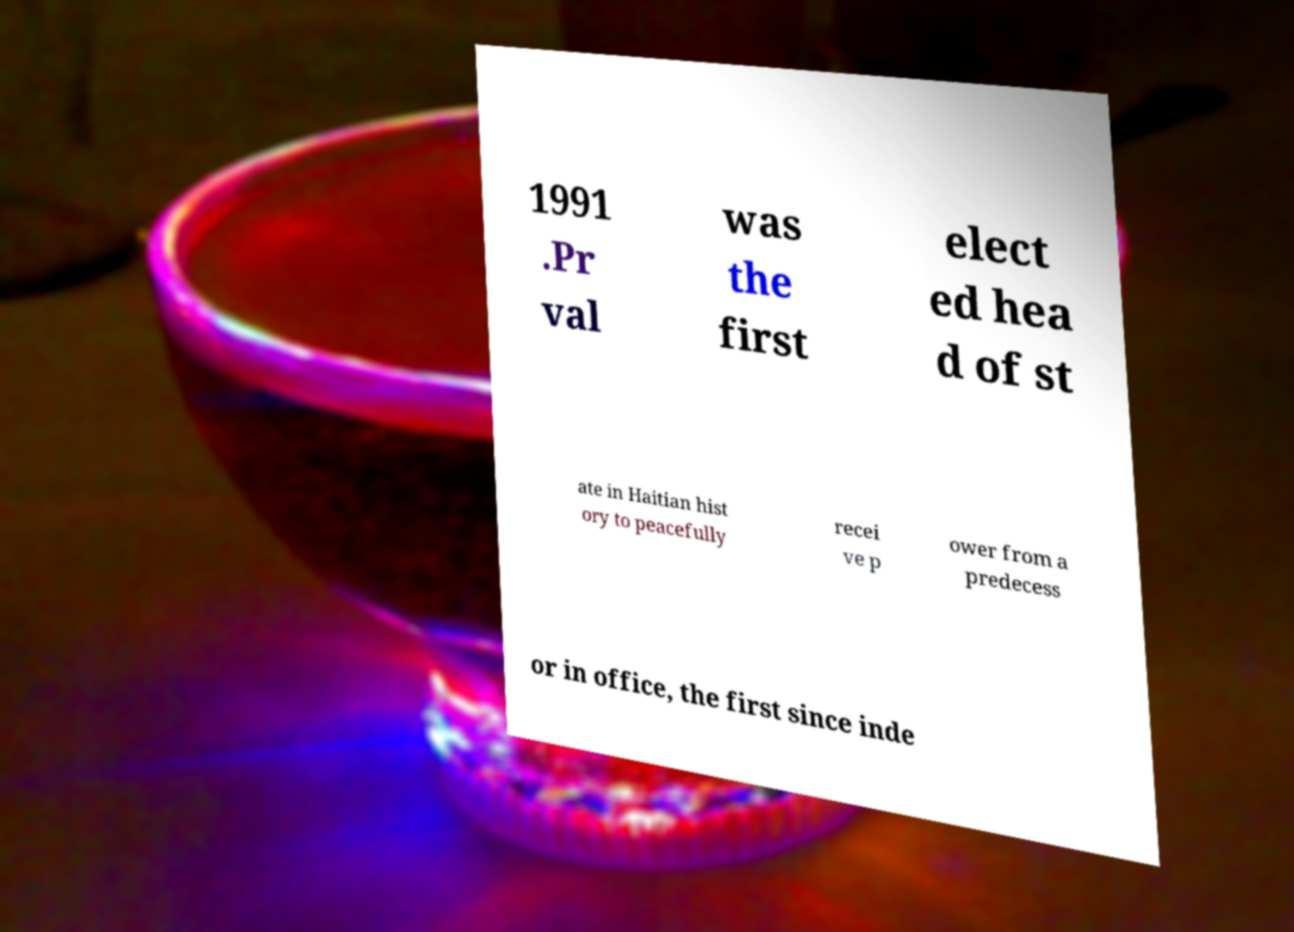Could you extract and type out the text from this image? 1991 .Pr val was the first elect ed hea d of st ate in Haitian hist ory to peacefully recei ve p ower from a predecess or in office, the first since inde 